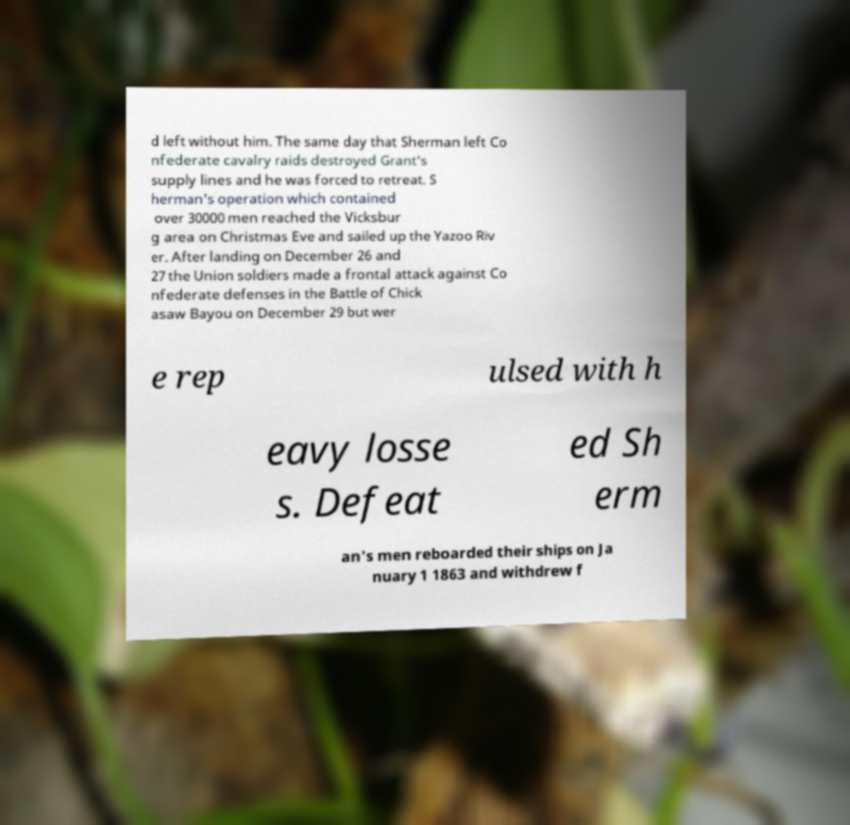Please identify and transcribe the text found in this image. d left without him. The same day that Sherman left Co nfederate cavalry raids destroyed Grant's supply lines and he was forced to retreat. S herman's operation which contained over 30000 men reached the Vicksbur g area on Christmas Eve and sailed up the Yazoo Riv er. After landing on December 26 and 27 the Union soldiers made a frontal attack against Co nfederate defenses in the Battle of Chick asaw Bayou on December 29 but wer e rep ulsed with h eavy losse s. Defeat ed Sh erm an's men reboarded their ships on Ja nuary 1 1863 and withdrew f 